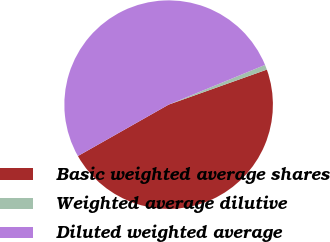Convert chart to OTSL. <chart><loc_0><loc_0><loc_500><loc_500><pie_chart><fcel>Basic weighted average shares<fcel>Weighted average dilutive<fcel>Diluted weighted average<nl><fcel>47.25%<fcel>0.77%<fcel>51.98%<nl></chart> 